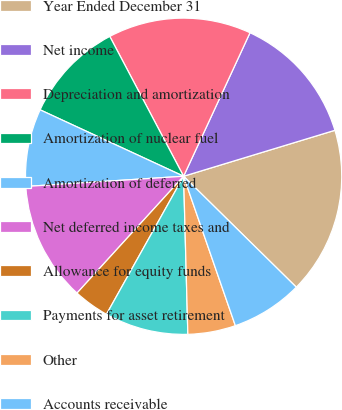Convert chart. <chart><loc_0><loc_0><loc_500><loc_500><pie_chart><fcel>Year Ended December 31<fcel>Net income<fcel>Depreciation and amortization<fcel>Amortization of nuclear fuel<fcel>Amortization of deferred<fcel>Net deferred income taxes and<fcel>Allowance for equity funds<fcel>Payments for asset retirement<fcel>Other<fcel>Accounts receivable<nl><fcel>17.07%<fcel>13.41%<fcel>14.63%<fcel>10.37%<fcel>7.93%<fcel>12.2%<fcel>3.66%<fcel>8.54%<fcel>4.88%<fcel>7.32%<nl></chart> 